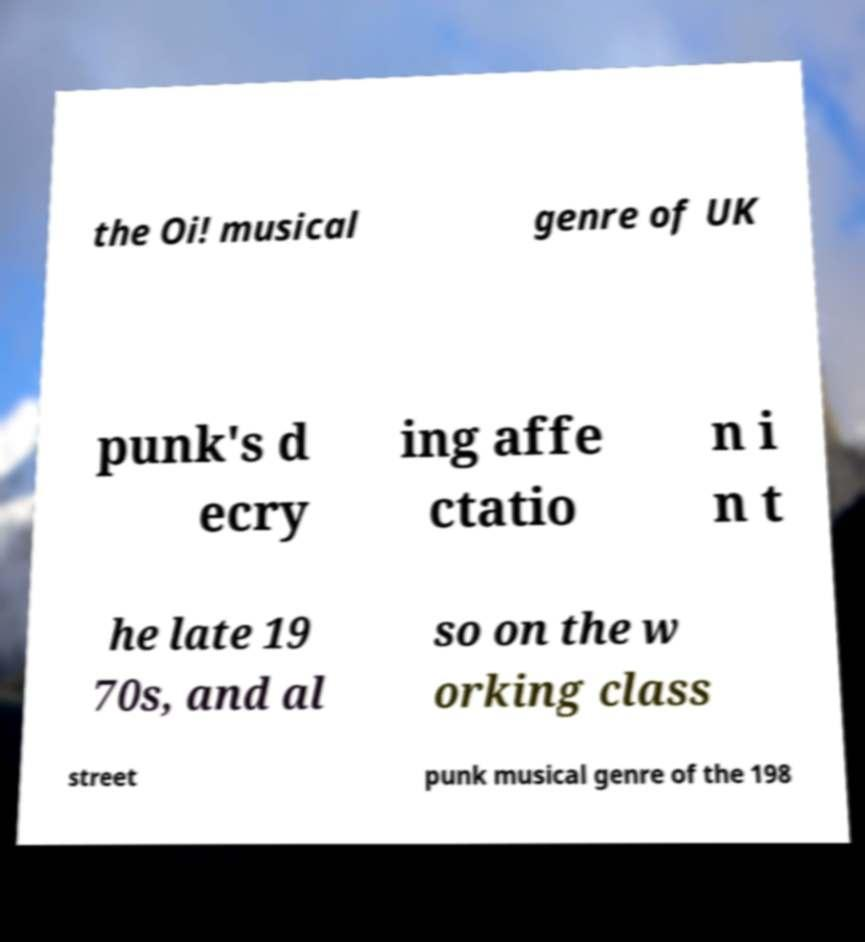For documentation purposes, I need the text within this image transcribed. Could you provide that? the Oi! musical genre of UK punk's d ecry ing affe ctatio n i n t he late 19 70s, and al so on the w orking class street punk musical genre of the 198 